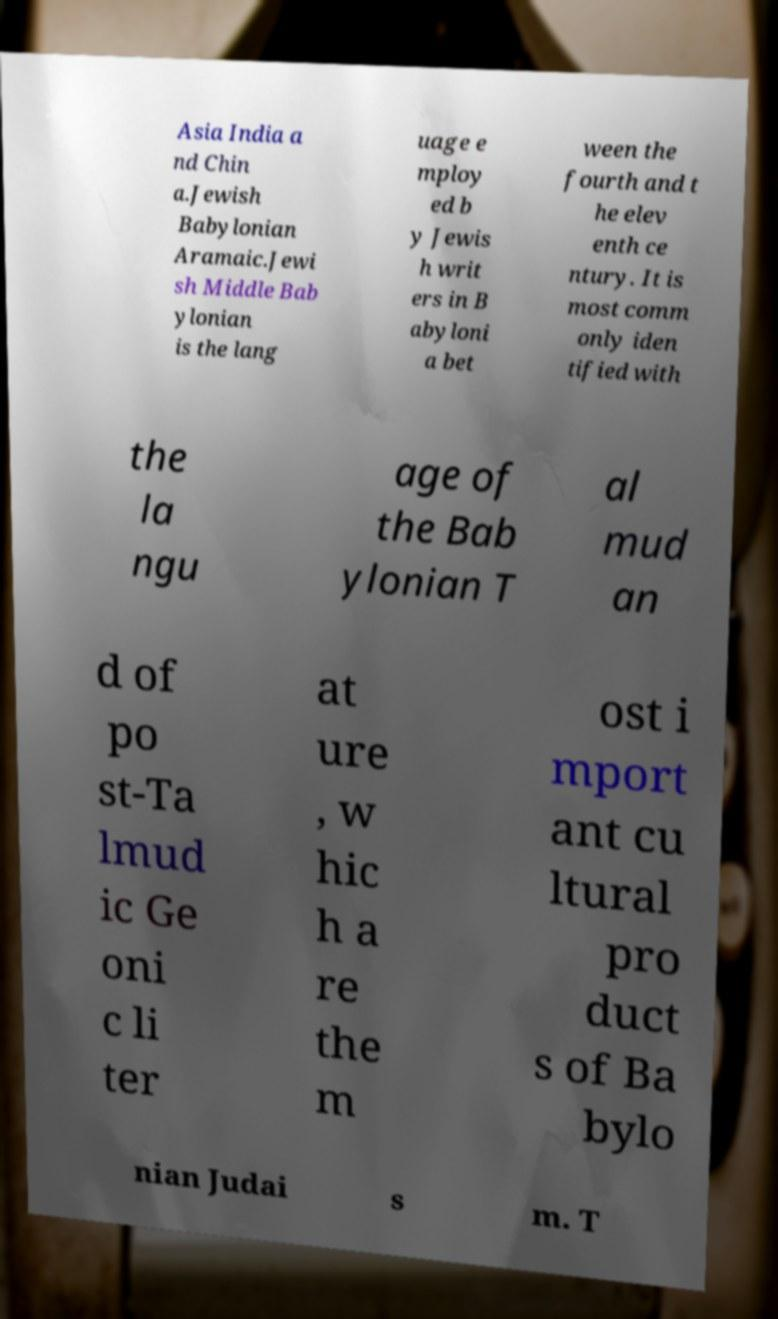Can you accurately transcribe the text from the provided image for me? Asia India a nd Chin a.Jewish Babylonian Aramaic.Jewi sh Middle Bab ylonian is the lang uage e mploy ed b y Jewis h writ ers in B abyloni a bet ween the fourth and t he elev enth ce ntury. It is most comm only iden tified with the la ngu age of the Bab ylonian T al mud an d of po st-Ta lmud ic Ge oni c li ter at ure , w hic h a re the m ost i mport ant cu ltural pro duct s of Ba bylo nian Judai s m. T 